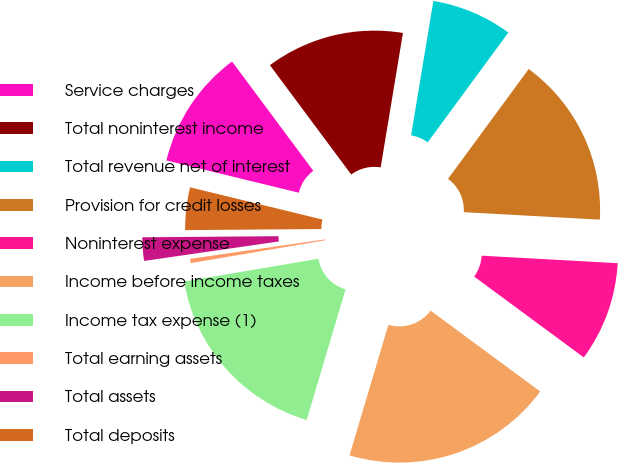<chart> <loc_0><loc_0><loc_500><loc_500><pie_chart><fcel>Service charges<fcel>Total noninterest income<fcel>Total revenue net of interest<fcel>Provision for credit losses<fcel>Noninterest expense<fcel>Income before income taxes<fcel>Income tax expense (1)<fcel>Total earning assets<fcel>Total assets<fcel>Total deposits<nl><fcel>11.02%<fcel>12.79%<fcel>7.47%<fcel>15.79%<fcel>9.24%<fcel>19.49%<fcel>17.72%<fcel>0.39%<fcel>2.16%<fcel>3.93%<nl></chart> 